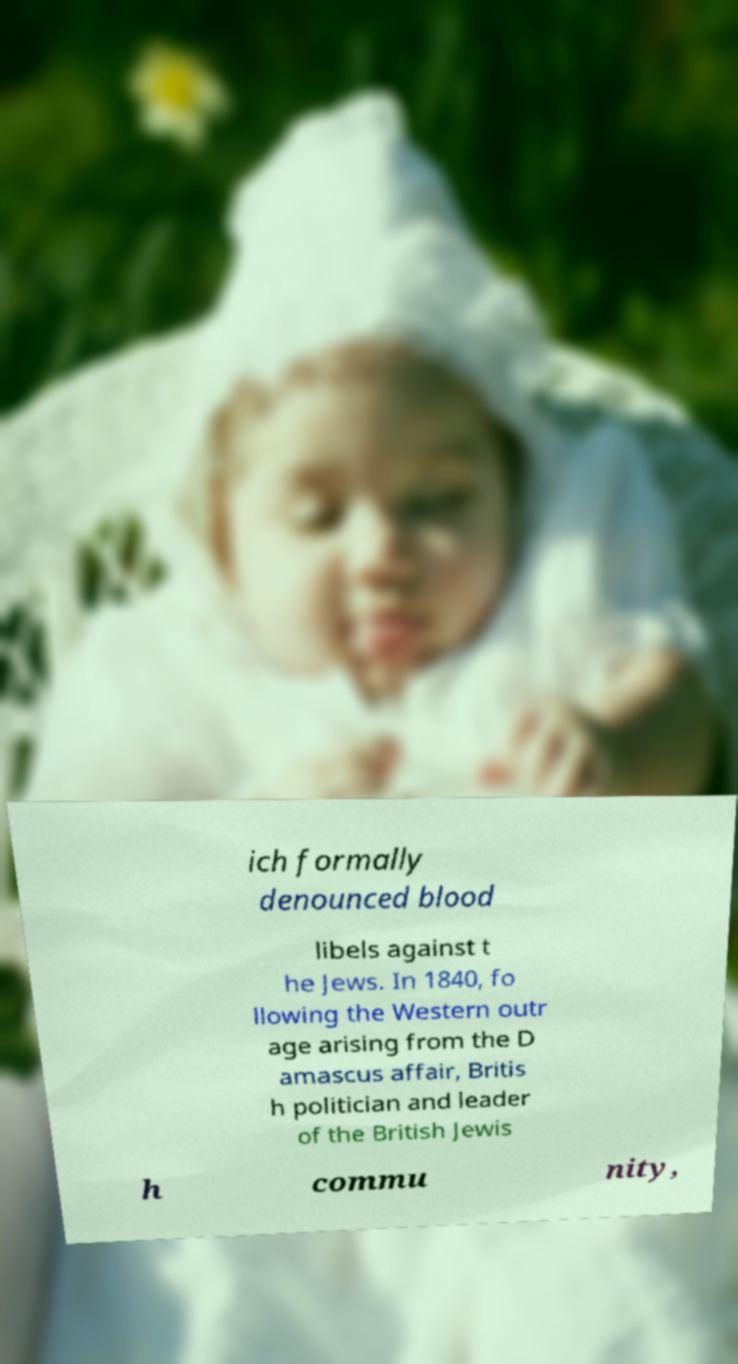Can you accurately transcribe the text from the provided image for me? ich formally denounced blood libels against t he Jews. In 1840, fo llowing the Western outr age arising from the D amascus affair, Britis h politician and leader of the British Jewis h commu nity, 